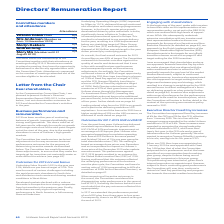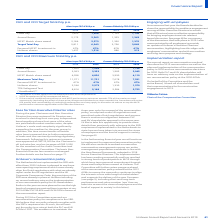According to Unilever Plc's financial document, What is the increase in the Fixed Pay approved by the committee? The Committee has approved Fixed Pay increases of 4% for the CEO and 3% for the CFO, effective from 1 January 2020.. The document states: "The Committee has approved Fixed Pay increases of 4% for the CEO and 3% for the CFO, effective from 1 January 2020. This is in line with the average i..." Also, Who were these increases awarded to? These increases were awarded to recognise the strong leadership of both individuals in 2019, which was Alan Jope’s first year in the CEO role and a year of transformation for Unilever generally. We also wanted to recognise Graeme Pitkethly’s seniority in his role, coming into his 5th year as CFO.. The document states: "d to the wider Unilever workforce in 2019 of 3.6%. These increases were awarded to recognise the strong leadership of both individuals in 2019, which ..." Also, What was the Fixed Pay percentage when CEO Alan Jope joined? According to the financial document, 14%. The relevant text states: "on 1 January 2019 he was appointed with Fixed Pay 14% below that of what the Committee proposed for his predecessor and at the lower quartile of our remun..." Also, can you calculate: What is the increase / (decrease) in Fixed Pay for Alan Jope CEO from 2019 to 2020? Based on the calculation: 1,450 - 1,508, the result is -58 (in millions). This is based on the information: "Fixed Pay 1,450 1,508 1,103 1,136 Fixed Pay 1,450 1,508 1,103 1,136..." The key data points involved are: 1,450, 1,508. Also, can you calculate: What is the percentage difference between the Fixed pay of CEO and CFO in 2020? To answer this question, I need to perform calculations using the financial data. The calculation is: 1,508 / 1,136 - 1, which equals 32.75 (percentage). This is based on the information: "Fixed Pay 1,450 1,508 1,103 1,136 Fixed Pay 1,450 1,508 1,103 1,136..." The key data points involved are: 1,136, 1,508. Also, can you calculate: What is the difference in the target total pay between CEO and CFO in 2020? Based on the calculation: 6,043 - 3,869, the result is 2174 (in millions). This is based on the information: "Target Total Pay 5,811 6,043 3,756 3,869 Target Total Pay 5,811 6,043 3,756 3,869..." The key data points involved are: 3,869, 6,043. 